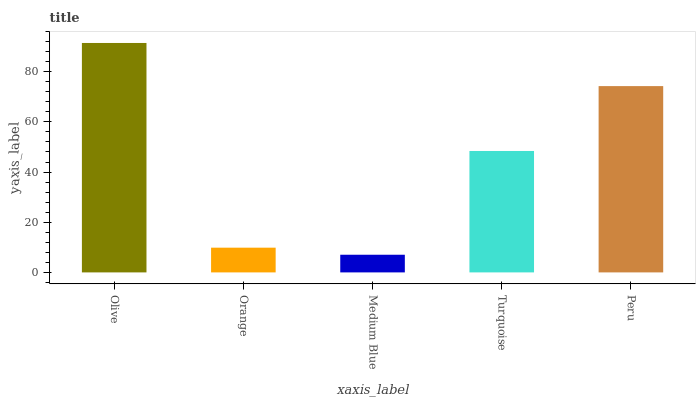Is Medium Blue the minimum?
Answer yes or no. Yes. Is Olive the maximum?
Answer yes or no. Yes. Is Orange the minimum?
Answer yes or no. No. Is Orange the maximum?
Answer yes or no. No. Is Olive greater than Orange?
Answer yes or no. Yes. Is Orange less than Olive?
Answer yes or no. Yes. Is Orange greater than Olive?
Answer yes or no. No. Is Olive less than Orange?
Answer yes or no. No. Is Turquoise the high median?
Answer yes or no. Yes. Is Turquoise the low median?
Answer yes or no. Yes. Is Orange the high median?
Answer yes or no. No. Is Olive the low median?
Answer yes or no. No. 